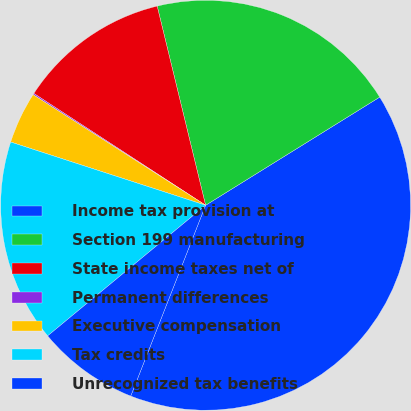<chart> <loc_0><loc_0><loc_500><loc_500><pie_chart><fcel>Income tax provision at<fcel>Section 199 manufacturing<fcel>State income taxes net of<fcel>Permanent differences<fcel>Executive compensation<fcel>Tax credits<fcel>Unrecognized tax benefits<nl><fcel>39.8%<fcel>19.95%<fcel>12.02%<fcel>0.11%<fcel>4.08%<fcel>15.99%<fcel>8.05%<nl></chart> 